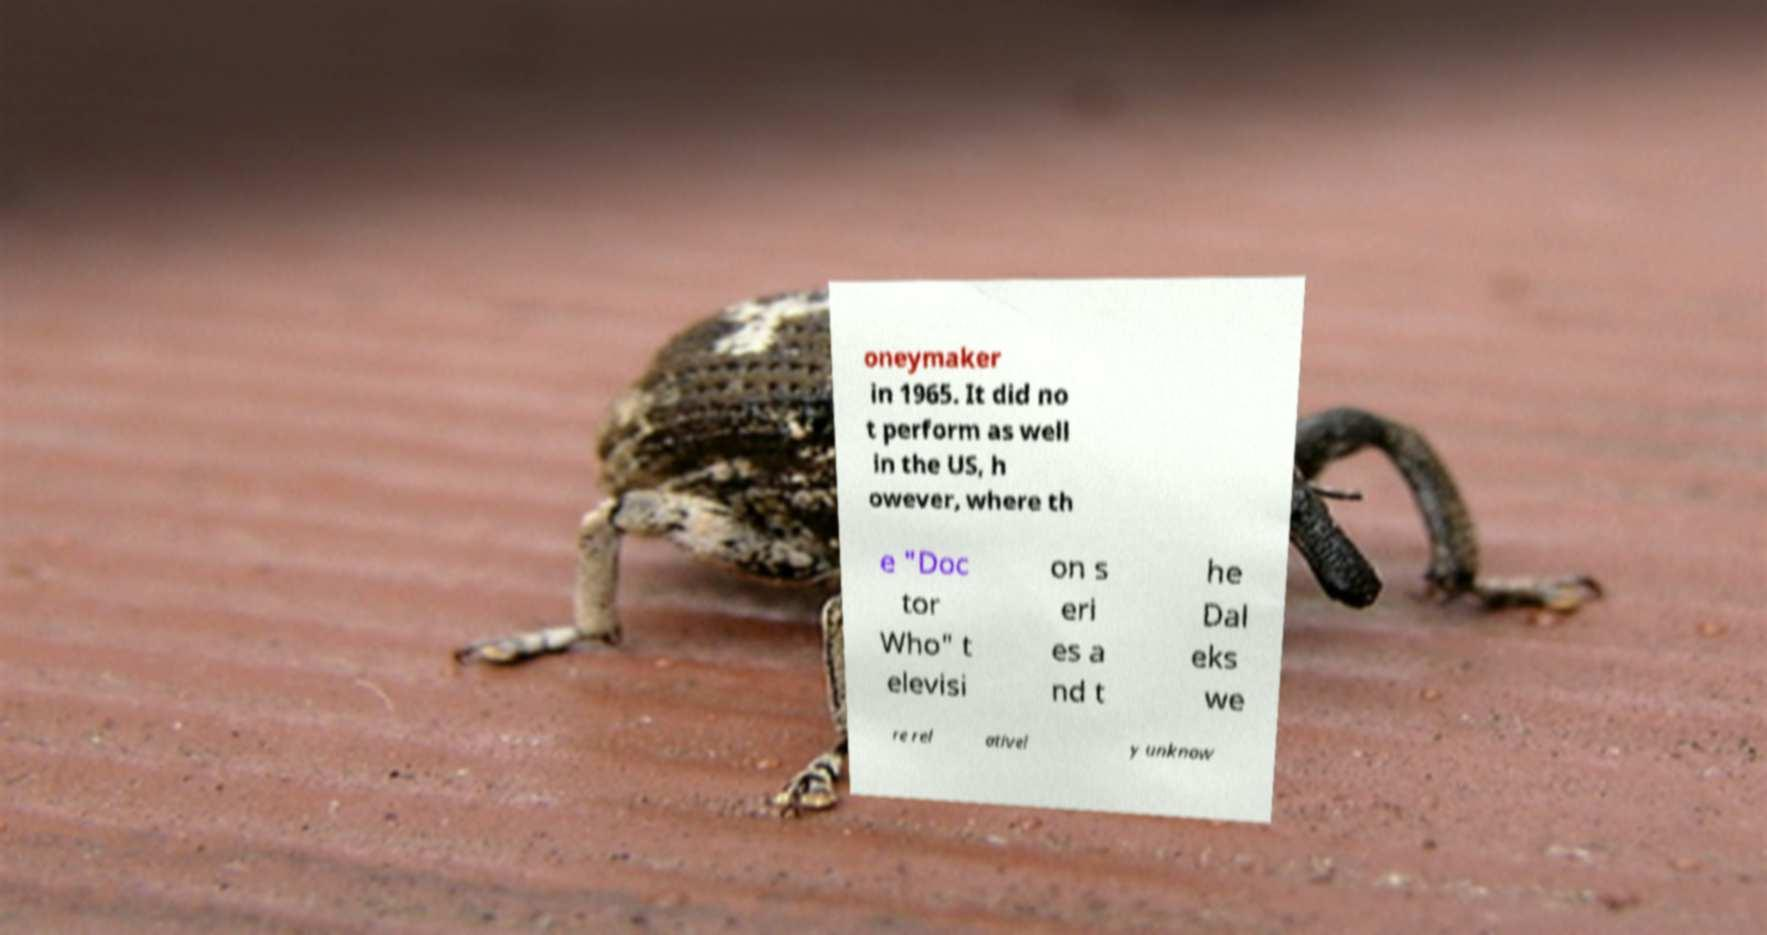Can you accurately transcribe the text from the provided image for me? oneymaker in 1965. It did no t perform as well in the US, h owever, where th e "Doc tor Who" t elevisi on s eri es a nd t he Dal eks we re rel ativel y unknow 